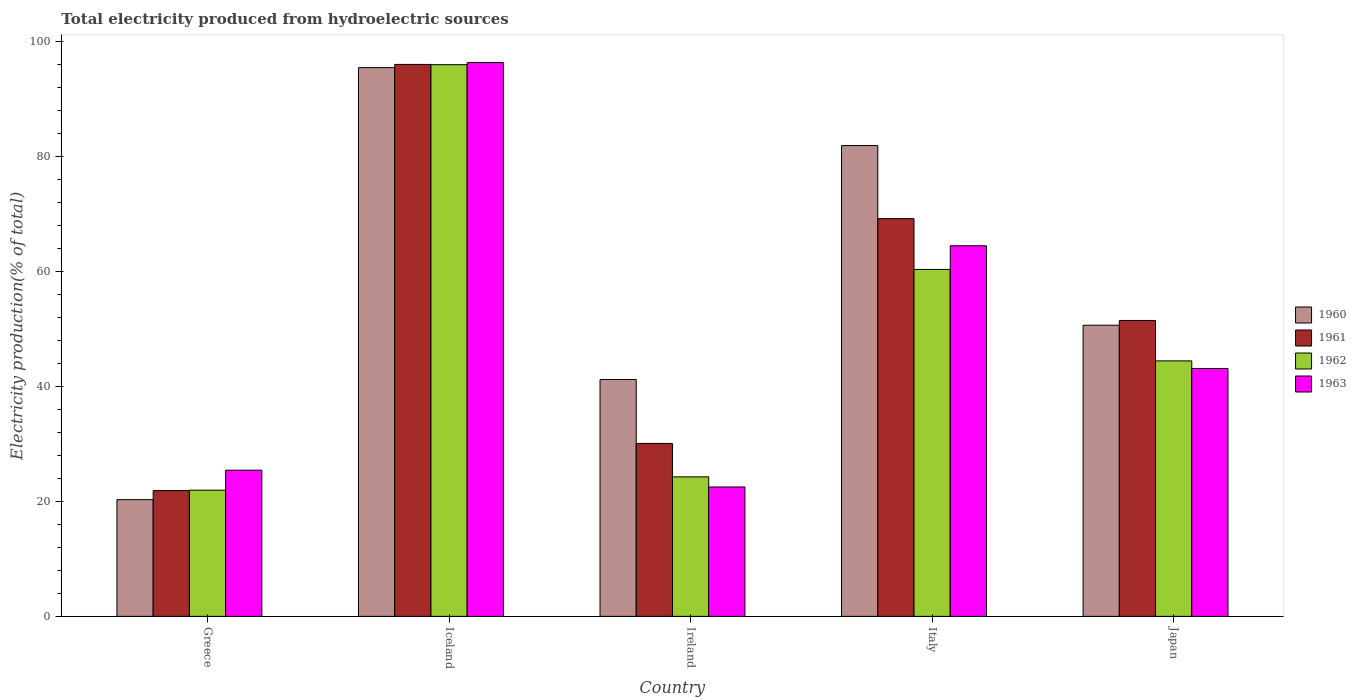How many different coloured bars are there?
Your answer should be compact. 4. How many groups of bars are there?
Provide a short and direct response. 5. Are the number of bars per tick equal to the number of legend labels?
Provide a short and direct response. Yes. Are the number of bars on each tick of the X-axis equal?
Your response must be concise. Yes. How many bars are there on the 1st tick from the right?
Your response must be concise. 4. What is the label of the 3rd group of bars from the left?
Offer a terse response. Ireland. In how many cases, is the number of bars for a given country not equal to the number of legend labels?
Ensure brevity in your answer.  0. What is the total electricity produced in 1963 in Ireland?
Make the answer very short. 22.51. Across all countries, what is the maximum total electricity produced in 1961?
Provide a short and direct response. 96.02. Across all countries, what is the minimum total electricity produced in 1963?
Keep it short and to the point. 22.51. What is the total total electricity produced in 1960 in the graph?
Ensure brevity in your answer.  289.52. What is the difference between the total electricity produced in 1962 in Greece and that in Ireland?
Ensure brevity in your answer.  -2.32. What is the difference between the total electricity produced in 1960 in Iceland and the total electricity produced in 1961 in Italy?
Offer a very short reply. 26.27. What is the average total electricity produced in 1961 per country?
Your response must be concise. 53.73. What is the difference between the total electricity produced of/in 1962 and total electricity produced of/in 1961 in Italy?
Your answer should be very brief. -8.84. What is the ratio of the total electricity produced in 1962 in Iceland to that in Japan?
Provide a succinct answer. 2.16. What is the difference between the highest and the second highest total electricity produced in 1962?
Your answer should be compact. 15.91. What is the difference between the highest and the lowest total electricity produced in 1963?
Offer a very short reply. 73.83. Is it the case that in every country, the sum of the total electricity produced in 1963 and total electricity produced in 1962 is greater than the sum of total electricity produced in 1960 and total electricity produced in 1961?
Make the answer very short. No. What does the 1st bar from the left in Italy represents?
Provide a succinct answer. 1960. Is it the case that in every country, the sum of the total electricity produced in 1963 and total electricity produced in 1961 is greater than the total electricity produced in 1960?
Offer a terse response. Yes. Does the graph contain any zero values?
Provide a succinct answer. No. How many legend labels are there?
Your answer should be very brief. 4. How are the legend labels stacked?
Keep it short and to the point. Vertical. What is the title of the graph?
Keep it short and to the point. Total electricity produced from hydroelectric sources. Does "1960" appear as one of the legend labels in the graph?
Offer a terse response. Yes. What is the label or title of the X-axis?
Ensure brevity in your answer.  Country. What is the Electricity production(% of total) of 1960 in Greece?
Ensure brevity in your answer.  20.31. What is the Electricity production(% of total) in 1961 in Greece?
Your answer should be compact. 21.88. What is the Electricity production(% of total) in 1962 in Greece?
Provide a short and direct response. 21.95. What is the Electricity production(% of total) of 1963 in Greece?
Offer a very short reply. 25.43. What is the Electricity production(% of total) in 1960 in Iceland?
Your answer should be very brief. 95.46. What is the Electricity production(% of total) in 1961 in Iceland?
Keep it short and to the point. 96.02. What is the Electricity production(% of total) in 1962 in Iceland?
Give a very brief answer. 95.97. What is the Electricity production(% of total) in 1963 in Iceland?
Offer a terse response. 96.34. What is the Electricity production(% of total) of 1960 in Ireland?
Offer a very short reply. 41.2. What is the Electricity production(% of total) in 1961 in Ireland?
Keep it short and to the point. 30.09. What is the Electricity production(% of total) in 1962 in Ireland?
Your response must be concise. 24.27. What is the Electricity production(% of total) in 1963 in Ireland?
Provide a short and direct response. 22.51. What is the Electricity production(% of total) of 1960 in Italy?
Give a very brief answer. 81.9. What is the Electricity production(% of total) of 1961 in Italy?
Your answer should be very brief. 69.19. What is the Electricity production(% of total) of 1962 in Italy?
Keep it short and to the point. 60.35. What is the Electricity production(% of total) of 1963 in Italy?
Give a very brief answer. 64.47. What is the Electricity production(% of total) of 1960 in Japan?
Ensure brevity in your answer.  50.65. What is the Electricity production(% of total) in 1961 in Japan?
Provide a succinct answer. 51.48. What is the Electricity production(% of total) in 1962 in Japan?
Your answer should be compact. 44.44. What is the Electricity production(% of total) of 1963 in Japan?
Provide a succinct answer. 43.11. Across all countries, what is the maximum Electricity production(% of total) of 1960?
Offer a terse response. 95.46. Across all countries, what is the maximum Electricity production(% of total) in 1961?
Provide a short and direct response. 96.02. Across all countries, what is the maximum Electricity production(% of total) of 1962?
Your answer should be very brief. 95.97. Across all countries, what is the maximum Electricity production(% of total) of 1963?
Keep it short and to the point. 96.34. Across all countries, what is the minimum Electricity production(% of total) of 1960?
Make the answer very short. 20.31. Across all countries, what is the minimum Electricity production(% of total) of 1961?
Provide a short and direct response. 21.88. Across all countries, what is the minimum Electricity production(% of total) of 1962?
Offer a terse response. 21.95. Across all countries, what is the minimum Electricity production(% of total) in 1963?
Your answer should be very brief. 22.51. What is the total Electricity production(% of total) in 1960 in the graph?
Provide a short and direct response. 289.52. What is the total Electricity production(% of total) in 1961 in the graph?
Make the answer very short. 268.65. What is the total Electricity production(% of total) of 1962 in the graph?
Provide a short and direct response. 247. What is the total Electricity production(% of total) in 1963 in the graph?
Your answer should be compact. 251.86. What is the difference between the Electricity production(% of total) in 1960 in Greece and that in Iceland?
Your answer should be very brief. -75.16. What is the difference between the Electricity production(% of total) in 1961 in Greece and that in Iceland?
Your answer should be very brief. -74.14. What is the difference between the Electricity production(% of total) of 1962 in Greece and that in Iceland?
Your answer should be very brief. -74.02. What is the difference between the Electricity production(% of total) of 1963 in Greece and that in Iceland?
Offer a terse response. -70.91. What is the difference between the Electricity production(% of total) in 1960 in Greece and that in Ireland?
Offer a terse response. -20.9. What is the difference between the Electricity production(% of total) in 1961 in Greece and that in Ireland?
Your answer should be very brief. -8.2. What is the difference between the Electricity production(% of total) in 1962 in Greece and that in Ireland?
Keep it short and to the point. -2.32. What is the difference between the Electricity production(% of total) of 1963 in Greece and that in Ireland?
Give a very brief answer. 2.92. What is the difference between the Electricity production(% of total) in 1960 in Greece and that in Italy?
Your answer should be very brief. -61.59. What is the difference between the Electricity production(% of total) in 1961 in Greece and that in Italy?
Offer a terse response. -47.31. What is the difference between the Electricity production(% of total) of 1962 in Greece and that in Italy?
Provide a short and direct response. -38.4. What is the difference between the Electricity production(% of total) of 1963 in Greece and that in Italy?
Make the answer very short. -39.04. What is the difference between the Electricity production(% of total) in 1960 in Greece and that in Japan?
Keep it short and to the point. -30.34. What is the difference between the Electricity production(% of total) of 1961 in Greece and that in Japan?
Offer a terse response. -29.59. What is the difference between the Electricity production(% of total) of 1962 in Greece and that in Japan?
Provide a short and direct response. -22.49. What is the difference between the Electricity production(% of total) of 1963 in Greece and that in Japan?
Your answer should be compact. -17.69. What is the difference between the Electricity production(% of total) in 1960 in Iceland and that in Ireland?
Keep it short and to the point. 54.26. What is the difference between the Electricity production(% of total) in 1961 in Iceland and that in Ireland?
Keep it short and to the point. 65.93. What is the difference between the Electricity production(% of total) in 1962 in Iceland and that in Ireland?
Your answer should be compact. 71.7. What is the difference between the Electricity production(% of total) in 1963 in Iceland and that in Ireland?
Provide a short and direct response. 73.83. What is the difference between the Electricity production(% of total) of 1960 in Iceland and that in Italy?
Offer a terse response. 13.56. What is the difference between the Electricity production(% of total) in 1961 in Iceland and that in Italy?
Keep it short and to the point. 26.83. What is the difference between the Electricity production(% of total) of 1962 in Iceland and that in Italy?
Keep it short and to the point. 35.62. What is the difference between the Electricity production(% of total) in 1963 in Iceland and that in Italy?
Provide a succinct answer. 31.87. What is the difference between the Electricity production(% of total) of 1960 in Iceland and that in Japan?
Keep it short and to the point. 44.81. What is the difference between the Electricity production(% of total) of 1961 in Iceland and that in Japan?
Make the answer very short. 44.54. What is the difference between the Electricity production(% of total) in 1962 in Iceland and that in Japan?
Offer a very short reply. 51.53. What is the difference between the Electricity production(% of total) in 1963 in Iceland and that in Japan?
Your answer should be very brief. 53.23. What is the difference between the Electricity production(% of total) of 1960 in Ireland and that in Italy?
Give a very brief answer. -40.7. What is the difference between the Electricity production(% of total) in 1961 in Ireland and that in Italy?
Provide a short and direct response. -39.1. What is the difference between the Electricity production(% of total) in 1962 in Ireland and that in Italy?
Keep it short and to the point. -36.08. What is the difference between the Electricity production(% of total) of 1963 in Ireland and that in Italy?
Provide a short and direct response. -41.96. What is the difference between the Electricity production(% of total) of 1960 in Ireland and that in Japan?
Offer a very short reply. -9.45. What is the difference between the Electricity production(% of total) of 1961 in Ireland and that in Japan?
Your answer should be very brief. -21.39. What is the difference between the Electricity production(% of total) in 1962 in Ireland and that in Japan?
Your response must be concise. -20.17. What is the difference between the Electricity production(% of total) in 1963 in Ireland and that in Japan?
Offer a terse response. -20.61. What is the difference between the Electricity production(% of total) in 1960 in Italy and that in Japan?
Provide a short and direct response. 31.25. What is the difference between the Electricity production(% of total) in 1961 in Italy and that in Japan?
Your answer should be compact. 17.71. What is the difference between the Electricity production(% of total) in 1962 in Italy and that in Japan?
Ensure brevity in your answer.  15.91. What is the difference between the Electricity production(% of total) in 1963 in Italy and that in Japan?
Give a very brief answer. 21.35. What is the difference between the Electricity production(% of total) of 1960 in Greece and the Electricity production(% of total) of 1961 in Iceland?
Your response must be concise. -75.71. What is the difference between the Electricity production(% of total) in 1960 in Greece and the Electricity production(% of total) in 1962 in Iceland?
Your answer should be very brief. -75.67. What is the difference between the Electricity production(% of total) in 1960 in Greece and the Electricity production(% of total) in 1963 in Iceland?
Provide a succinct answer. -76.04. What is the difference between the Electricity production(% of total) of 1961 in Greece and the Electricity production(% of total) of 1962 in Iceland?
Offer a terse response. -74.09. What is the difference between the Electricity production(% of total) in 1961 in Greece and the Electricity production(% of total) in 1963 in Iceland?
Provide a short and direct response. -74.46. What is the difference between the Electricity production(% of total) in 1962 in Greece and the Electricity production(% of total) in 1963 in Iceland?
Offer a terse response. -74.39. What is the difference between the Electricity production(% of total) of 1960 in Greece and the Electricity production(% of total) of 1961 in Ireland?
Make the answer very short. -9.78. What is the difference between the Electricity production(% of total) in 1960 in Greece and the Electricity production(% of total) in 1962 in Ireland?
Make the answer very short. -3.97. What is the difference between the Electricity production(% of total) of 1960 in Greece and the Electricity production(% of total) of 1963 in Ireland?
Provide a succinct answer. -2.2. What is the difference between the Electricity production(% of total) in 1961 in Greece and the Electricity production(% of total) in 1962 in Ireland?
Make the answer very short. -2.39. What is the difference between the Electricity production(% of total) of 1961 in Greece and the Electricity production(% of total) of 1963 in Ireland?
Provide a succinct answer. -0.63. What is the difference between the Electricity production(% of total) in 1962 in Greece and the Electricity production(% of total) in 1963 in Ireland?
Keep it short and to the point. -0.56. What is the difference between the Electricity production(% of total) of 1960 in Greece and the Electricity production(% of total) of 1961 in Italy?
Give a very brief answer. -48.88. What is the difference between the Electricity production(% of total) in 1960 in Greece and the Electricity production(% of total) in 1962 in Italy?
Make the answer very short. -40.05. What is the difference between the Electricity production(% of total) in 1960 in Greece and the Electricity production(% of total) in 1963 in Italy?
Your answer should be very brief. -44.16. What is the difference between the Electricity production(% of total) of 1961 in Greece and the Electricity production(% of total) of 1962 in Italy?
Provide a short and direct response. -38.47. What is the difference between the Electricity production(% of total) in 1961 in Greece and the Electricity production(% of total) in 1963 in Italy?
Your answer should be compact. -42.58. What is the difference between the Electricity production(% of total) of 1962 in Greece and the Electricity production(% of total) of 1963 in Italy?
Provide a succinct answer. -42.52. What is the difference between the Electricity production(% of total) of 1960 in Greece and the Electricity production(% of total) of 1961 in Japan?
Your answer should be compact. -31.17. What is the difference between the Electricity production(% of total) of 1960 in Greece and the Electricity production(% of total) of 1962 in Japan?
Give a very brief answer. -24.14. What is the difference between the Electricity production(% of total) in 1960 in Greece and the Electricity production(% of total) in 1963 in Japan?
Your answer should be compact. -22.81. What is the difference between the Electricity production(% of total) in 1961 in Greece and the Electricity production(% of total) in 1962 in Japan?
Offer a very short reply. -22.56. What is the difference between the Electricity production(% of total) of 1961 in Greece and the Electricity production(% of total) of 1963 in Japan?
Offer a terse response. -21.23. What is the difference between the Electricity production(% of total) in 1962 in Greece and the Electricity production(% of total) in 1963 in Japan?
Your answer should be very brief. -21.16. What is the difference between the Electricity production(% of total) in 1960 in Iceland and the Electricity production(% of total) in 1961 in Ireland?
Keep it short and to the point. 65.38. What is the difference between the Electricity production(% of total) of 1960 in Iceland and the Electricity production(% of total) of 1962 in Ireland?
Keep it short and to the point. 71.19. What is the difference between the Electricity production(% of total) of 1960 in Iceland and the Electricity production(% of total) of 1963 in Ireland?
Offer a terse response. 72.95. What is the difference between the Electricity production(% of total) in 1961 in Iceland and the Electricity production(% of total) in 1962 in Ireland?
Provide a short and direct response. 71.75. What is the difference between the Electricity production(% of total) in 1961 in Iceland and the Electricity production(% of total) in 1963 in Ireland?
Keep it short and to the point. 73.51. What is the difference between the Electricity production(% of total) in 1962 in Iceland and the Electricity production(% of total) in 1963 in Ireland?
Your response must be concise. 73.47. What is the difference between the Electricity production(% of total) in 1960 in Iceland and the Electricity production(% of total) in 1961 in Italy?
Give a very brief answer. 26.27. What is the difference between the Electricity production(% of total) in 1960 in Iceland and the Electricity production(% of total) in 1962 in Italy?
Offer a terse response. 35.11. What is the difference between the Electricity production(% of total) in 1960 in Iceland and the Electricity production(% of total) in 1963 in Italy?
Keep it short and to the point. 30.99. What is the difference between the Electricity production(% of total) of 1961 in Iceland and the Electricity production(% of total) of 1962 in Italy?
Offer a very short reply. 35.67. What is the difference between the Electricity production(% of total) of 1961 in Iceland and the Electricity production(% of total) of 1963 in Italy?
Offer a terse response. 31.55. What is the difference between the Electricity production(% of total) of 1962 in Iceland and the Electricity production(% of total) of 1963 in Italy?
Your answer should be compact. 31.51. What is the difference between the Electricity production(% of total) of 1960 in Iceland and the Electricity production(% of total) of 1961 in Japan?
Keep it short and to the point. 43.99. What is the difference between the Electricity production(% of total) of 1960 in Iceland and the Electricity production(% of total) of 1962 in Japan?
Keep it short and to the point. 51.02. What is the difference between the Electricity production(% of total) of 1960 in Iceland and the Electricity production(% of total) of 1963 in Japan?
Ensure brevity in your answer.  52.35. What is the difference between the Electricity production(% of total) of 1961 in Iceland and the Electricity production(% of total) of 1962 in Japan?
Keep it short and to the point. 51.58. What is the difference between the Electricity production(% of total) of 1961 in Iceland and the Electricity production(% of total) of 1963 in Japan?
Your response must be concise. 52.91. What is the difference between the Electricity production(% of total) of 1962 in Iceland and the Electricity production(% of total) of 1963 in Japan?
Offer a terse response. 52.86. What is the difference between the Electricity production(% of total) in 1960 in Ireland and the Electricity production(% of total) in 1961 in Italy?
Make the answer very short. -27.99. What is the difference between the Electricity production(% of total) of 1960 in Ireland and the Electricity production(% of total) of 1962 in Italy?
Ensure brevity in your answer.  -19.15. What is the difference between the Electricity production(% of total) in 1960 in Ireland and the Electricity production(% of total) in 1963 in Italy?
Your response must be concise. -23.27. What is the difference between the Electricity production(% of total) of 1961 in Ireland and the Electricity production(% of total) of 1962 in Italy?
Provide a short and direct response. -30.27. What is the difference between the Electricity production(% of total) in 1961 in Ireland and the Electricity production(% of total) in 1963 in Italy?
Your answer should be compact. -34.38. What is the difference between the Electricity production(% of total) in 1962 in Ireland and the Electricity production(% of total) in 1963 in Italy?
Your answer should be very brief. -40.2. What is the difference between the Electricity production(% of total) in 1960 in Ireland and the Electricity production(% of total) in 1961 in Japan?
Keep it short and to the point. -10.27. What is the difference between the Electricity production(% of total) in 1960 in Ireland and the Electricity production(% of total) in 1962 in Japan?
Make the answer very short. -3.24. What is the difference between the Electricity production(% of total) in 1960 in Ireland and the Electricity production(% of total) in 1963 in Japan?
Offer a terse response. -1.91. What is the difference between the Electricity production(% of total) in 1961 in Ireland and the Electricity production(% of total) in 1962 in Japan?
Keep it short and to the point. -14.36. What is the difference between the Electricity production(% of total) in 1961 in Ireland and the Electricity production(% of total) in 1963 in Japan?
Offer a very short reply. -13.03. What is the difference between the Electricity production(% of total) in 1962 in Ireland and the Electricity production(% of total) in 1963 in Japan?
Your answer should be compact. -18.84. What is the difference between the Electricity production(% of total) in 1960 in Italy and the Electricity production(% of total) in 1961 in Japan?
Make the answer very short. 30.42. What is the difference between the Electricity production(% of total) of 1960 in Italy and the Electricity production(% of total) of 1962 in Japan?
Provide a succinct answer. 37.46. What is the difference between the Electricity production(% of total) in 1960 in Italy and the Electricity production(% of total) in 1963 in Japan?
Provide a short and direct response. 38.79. What is the difference between the Electricity production(% of total) in 1961 in Italy and the Electricity production(% of total) in 1962 in Japan?
Offer a terse response. 24.75. What is the difference between the Electricity production(% of total) in 1961 in Italy and the Electricity production(% of total) in 1963 in Japan?
Offer a very short reply. 26.08. What is the difference between the Electricity production(% of total) in 1962 in Italy and the Electricity production(% of total) in 1963 in Japan?
Your answer should be compact. 17.24. What is the average Electricity production(% of total) of 1960 per country?
Your answer should be compact. 57.9. What is the average Electricity production(% of total) of 1961 per country?
Ensure brevity in your answer.  53.73. What is the average Electricity production(% of total) in 1962 per country?
Provide a short and direct response. 49.4. What is the average Electricity production(% of total) in 1963 per country?
Your answer should be compact. 50.37. What is the difference between the Electricity production(% of total) in 1960 and Electricity production(% of total) in 1961 in Greece?
Offer a terse response. -1.58. What is the difference between the Electricity production(% of total) in 1960 and Electricity production(% of total) in 1962 in Greece?
Give a very brief answer. -1.64. What is the difference between the Electricity production(% of total) of 1960 and Electricity production(% of total) of 1963 in Greece?
Provide a succinct answer. -5.12. What is the difference between the Electricity production(% of total) in 1961 and Electricity production(% of total) in 1962 in Greece?
Your response must be concise. -0.07. What is the difference between the Electricity production(% of total) of 1961 and Electricity production(% of total) of 1963 in Greece?
Provide a short and direct response. -3.54. What is the difference between the Electricity production(% of total) in 1962 and Electricity production(% of total) in 1963 in Greece?
Ensure brevity in your answer.  -3.48. What is the difference between the Electricity production(% of total) of 1960 and Electricity production(% of total) of 1961 in Iceland?
Keep it short and to the point. -0.56. What is the difference between the Electricity production(% of total) in 1960 and Electricity production(% of total) in 1962 in Iceland?
Provide a short and direct response. -0.51. What is the difference between the Electricity production(% of total) of 1960 and Electricity production(% of total) of 1963 in Iceland?
Your response must be concise. -0.88. What is the difference between the Electricity production(% of total) of 1961 and Electricity production(% of total) of 1962 in Iceland?
Ensure brevity in your answer.  0.05. What is the difference between the Electricity production(% of total) in 1961 and Electricity production(% of total) in 1963 in Iceland?
Provide a succinct answer. -0.32. What is the difference between the Electricity production(% of total) of 1962 and Electricity production(% of total) of 1963 in Iceland?
Your answer should be compact. -0.37. What is the difference between the Electricity production(% of total) in 1960 and Electricity production(% of total) in 1961 in Ireland?
Keep it short and to the point. 11.12. What is the difference between the Electricity production(% of total) of 1960 and Electricity production(% of total) of 1962 in Ireland?
Offer a very short reply. 16.93. What is the difference between the Electricity production(% of total) in 1960 and Electricity production(% of total) in 1963 in Ireland?
Keep it short and to the point. 18.69. What is the difference between the Electricity production(% of total) in 1961 and Electricity production(% of total) in 1962 in Ireland?
Give a very brief answer. 5.81. What is the difference between the Electricity production(% of total) of 1961 and Electricity production(% of total) of 1963 in Ireland?
Ensure brevity in your answer.  7.58. What is the difference between the Electricity production(% of total) of 1962 and Electricity production(% of total) of 1963 in Ireland?
Make the answer very short. 1.76. What is the difference between the Electricity production(% of total) of 1960 and Electricity production(% of total) of 1961 in Italy?
Ensure brevity in your answer.  12.71. What is the difference between the Electricity production(% of total) of 1960 and Electricity production(% of total) of 1962 in Italy?
Your answer should be very brief. 21.55. What is the difference between the Electricity production(% of total) in 1960 and Electricity production(% of total) in 1963 in Italy?
Your answer should be very brief. 17.43. What is the difference between the Electricity production(% of total) of 1961 and Electricity production(% of total) of 1962 in Italy?
Keep it short and to the point. 8.84. What is the difference between the Electricity production(% of total) in 1961 and Electricity production(% of total) in 1963 in Italy?
Offer a very short reply. 4.72. What is the difference between the Electricity production(% of total) of 1962 and Electricity production(% of total) of 1963 in Italy?
Your answer should be compact. -4.11. What is the difference between the Electricity production(% of total) of 1960 and Electricity production(% of total) of 1961 in Japan?
Provide a succinct answer. -0.83. What is the difference between the Electricity production(% of total) in 1960 and Electricity production(% of total) in 1962 in Japan?
Your response must be concise. 6.2. What is the difference between the Electricity production(% of total) of 1960 and Electricity production(% of total) of 1963 in Japan?
Your answer should be very brief. 7.54. What is the difference between the Electricity production(% of total) in 1961 and Electricity production(% of total) in 1962 in Japan?
Your response must be concise. 7.03. What is the difference between the Electricity production(% of total) of 1961 and Electricity production(% of total) of 1963 in Japan?
Provide a short and direct response. 8.36. What is the difference between the Electricity production(% of total) of 1962 and Electricity production(% of total) of 1963 in Japan?
Your response must be concise. 1.33. What is the ratio of the Electricity production(% of total) of 1960 in Greece to that in Iceland?
Offer a very short reply. 0.21. What is the ratio of the Electricity production(% of total) of 1961 in Greece to that in Iceland?
Offer a terse response. 0.23. What is the ratio of the Electricity production(% of total) of 1962 in Greece to that in Iceland?
Your response must be concise. 0.23. What is the ratio of the Electricity production(% of total) in 1963 in Greece to that in Iceland?
Provide a succinct answer. 0.26. What is the ratio of the Electricity production(% of total) in 1960 in Greece to that in Ireland?
Your answer should be very brief. 0.49. What is the ratio of the Electricity production(% of total) of 1961 in Greece to that in Ireland?
Ensure brevity in your answer.  0.73. What is the ratio of the Electricity production(% of total) of 1962 in Greece to that in Ireland?
Offer a terse response. 0.9. What is the ratio of the Electricity production(% of total) in 1963 in Greece to that in Ireland?
Your answer should be compact. 1.13. What is the ratio of the Electricity production(% of total) of 1960 in Greece to that in Italy?
Keep it short and to the point. 0.25. What is the ratio of the Electricity production(% of total) in 1961 in Greece to that in Italy?
Ensure brevity in your answer.  0.32. What is the ratio of the Electricity production(% of total) of 1962 in Greece to that in Italy?
Provide a succinct answer. 0.36. What is the ratio of the Electricity production(% of total) in 1963 in Greece to that in Italy?
Keep it short and to the point. 0.39. What is the ratio of the Electricity production(% of total) of 1960 in Greece to that in Japan?
Your answer should be compact. 0.4. What is the ratio of the Electricity production(% of total) of 1961 in Greece to that in Japan?
Ensure brevity in your answer.  0.43. What is the ratio of the Electricity production(% of total) of 1962 in Greece to that in Japan?
Make the answer very short. 0.49. What is the ratio of the Electricity production(% of total) of 1963 in Greece to that in Japan?
Keep it short and to the point. 0.59. What is the ratio of the Electricity production(% of total) in 1960 in Iceland to that in Ireland?
Your response must be concise. 2.32. What is the ratio of the Electricity production(% of total) in 1961 in Iceland to that in Ireland?
Your answer should be compact. 3.19. What is the ratio of the Electricity production(% of total) in 1962 in Iceland to that in Ireland?
Offer a terse response. 3.95. What is the ratio of the Electricity production(% of total) of 1963 in Iceland to that in Ireland?
Offer a terse response. 4.28. What is the ratio of the Electricity production(% of total) in 1960 in Iceland to that in Italy?
Offer a very short reply. 1.17. What is the ratio of the Electricity production(% of total) in 1961 in Iceland to that in Italy?
Your answer should be compact. 1.39. What is the ratio of the Electricity production(% of total) of 1962 in Iceland to that in Italy?
Provide a short and direct response. 1.59. What is the ratio of the Electricity production(% of total) of 1963 in Iceland to that in Italy?
Offer a very short reply. 1.49. What is the ratio of the Electricity production(% of total) in 1960 in Iceland to that in Japan?
Provide a short and direct response. 1.88. What is the ratio of the Electricity production(% of total) of 1961 in Iceland to that in Japan?
Your answer should be compact. 1.87. What is the ratio of the Electricity production(% of total) in 1962 in Iceland to that in Japan?
Make the answer very short. 2.16. What is the ratio of the Electricity production(% of total) of 1963 in Iceland to that in Japan?
Make the answer very short. 2.23. What is the ratio of the Electricity production(% of total) of 1960 in Ireland to that in Italy?
Provide a short and direct response. 0.5. What is the ratio of the Electricity production(% of total) in 1961 in Ireland to that in Italy?
Your answer should be compact. 0.43. What is the ratio of the Electricity production(% of total) in 1962 in Ireland to that in Italy?
Keep it short and to the point. 0.4. What is the ratio of the Electricity production(% of total) of 1963 in Ireland to that in Italy?
Provide a succinct answer. 0.35. What is the ratio of the Electricity production(% of total) of 1960 in Ireland to that in Japan?
Your response must be concise. 0.81. What is the ratio of the Electricity production(% of total) of 1961 in Ireland to that in Japan?
Your answer should be compact. 0.58. What is the ratio of the Electricity production(% of total) of 1962 in Ireland to that in Japan?
Ensure brevity in your answer.  0.55. What is the ratio of the Electricity production(% of total) of 1963 in Ireland to that in Japan?
Offer a terse response. 0.52. What is the ratio of the Electricity production(% of total) in 1960 in Italy to that in Japan?
Provide a short and direct response. 1.62. What is the ratio of the Electricity production(% of total) of 1961 in Italy to that in Japan?
Keep it short and to the point. 1.34. What is the ratio of the Electricity production(% of total) of 1962 in Italy to that in Japan?
Ensure brevity in your answer.  1.36. What is the ratio of the Electricity production(% of total) of 1963 in Italy to that in Japan?
Provide a succinct answer. 1.5. What is the difference between the highest and the second highest Electricity production(% of total) in 1960?
Make the answer very short. 13.56. What is the difference between the highest and the second highest Electricity production(% of total) in 1961?
Provide a short and direct response. 26.83. What is the difference between the highest and the second highest Electricity production(% of total) in 1962?
Provide a short and direct response. 35.62. What is the difference between the highest and the second highest Electricity production(% of total) of 1963?
Offer a very short reply. 31.87. What is the difference between the highest and the lowest Electricity production(% of total) of 1960?
Make the answer very short. 75.16. What is the difference between the highest and the lowest Electricity production(% of total) of 1961?
Your answer should be very brief. 74.14. What is the difference between the highest and the lowest Electricity production(% of total) of 1962?
Your answer should be very brief. 74.02. What is the difference between the highest and the lowest Electricity production(% of total) of 1963?
Your response must be concise. 73.83. 